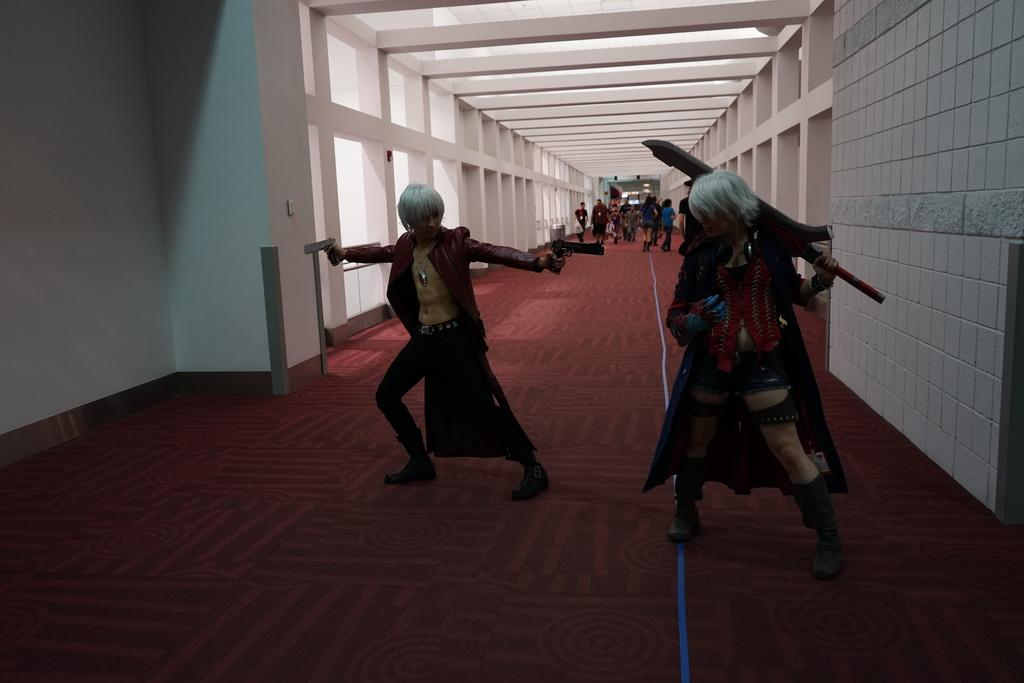What type of location is depicted in the image? The image is an inside picture of a building. What are the two persons in front doing? The two persons in front are standing and holding guns. What are the people behind the two persons with guns doing? The people behind the two persons with guns are walking on the floor. What type of jelly can be seen on the floor in the image? There is no jelly present in the image; it is an inside picture of a building with people holding guns and walking on the floor. 